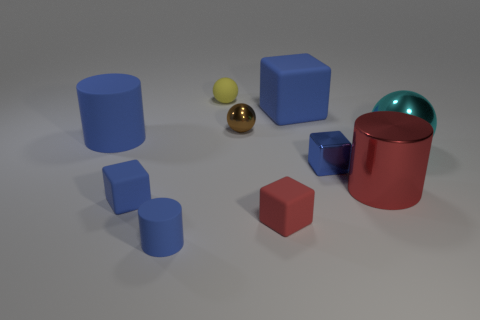Which objects appear to have a reflective surface? The large cylinder and the small sphere to its right both have reflective surfaces that stand out amongst the other objects. 